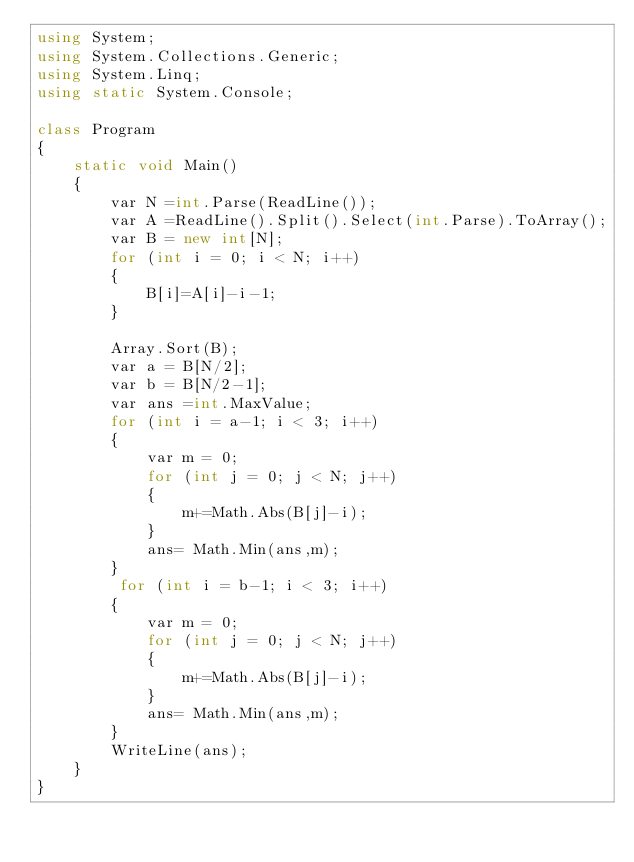<code> <loc_0><loc_0><loc_500><loc_500><_C#_>using System;
using System.Collections.Generic;
using System.Linq;
using static System.Console;

class Program
{
    static void Main()
    {
        var N =int.Parse(ReadLine());
        var A =ReadLine().Split().Select(int.Parse).ToArray();
        var B = new int[N];
        for (int i = 0; i < N; i++)
        {
            B[i]=A[i]-i-1;
        }
        
        Array.Sort(B);
        var a = B[N/2];
        var b = B[N/2-1];
        var ans =int.MaxValue;
        for (int i = a-1; i < 3; i++)
        {
            var m = 0;
            for (int j = 0; j < N; j++)
            {
                m+=Math.Abs(B[j]-i);
            }
            ans= Math.Min(ans,m);
        }
         for (int i = b-1; i < 3; i++)
        {
            var m = 0;
            for (int j = 0; j < N; j++)
            {
                m+=Math.Abs(B[j]-i);
            }
            ans= Math.Min(ans,m);
        }
        WriteLine(ans);
    }
}</code> 